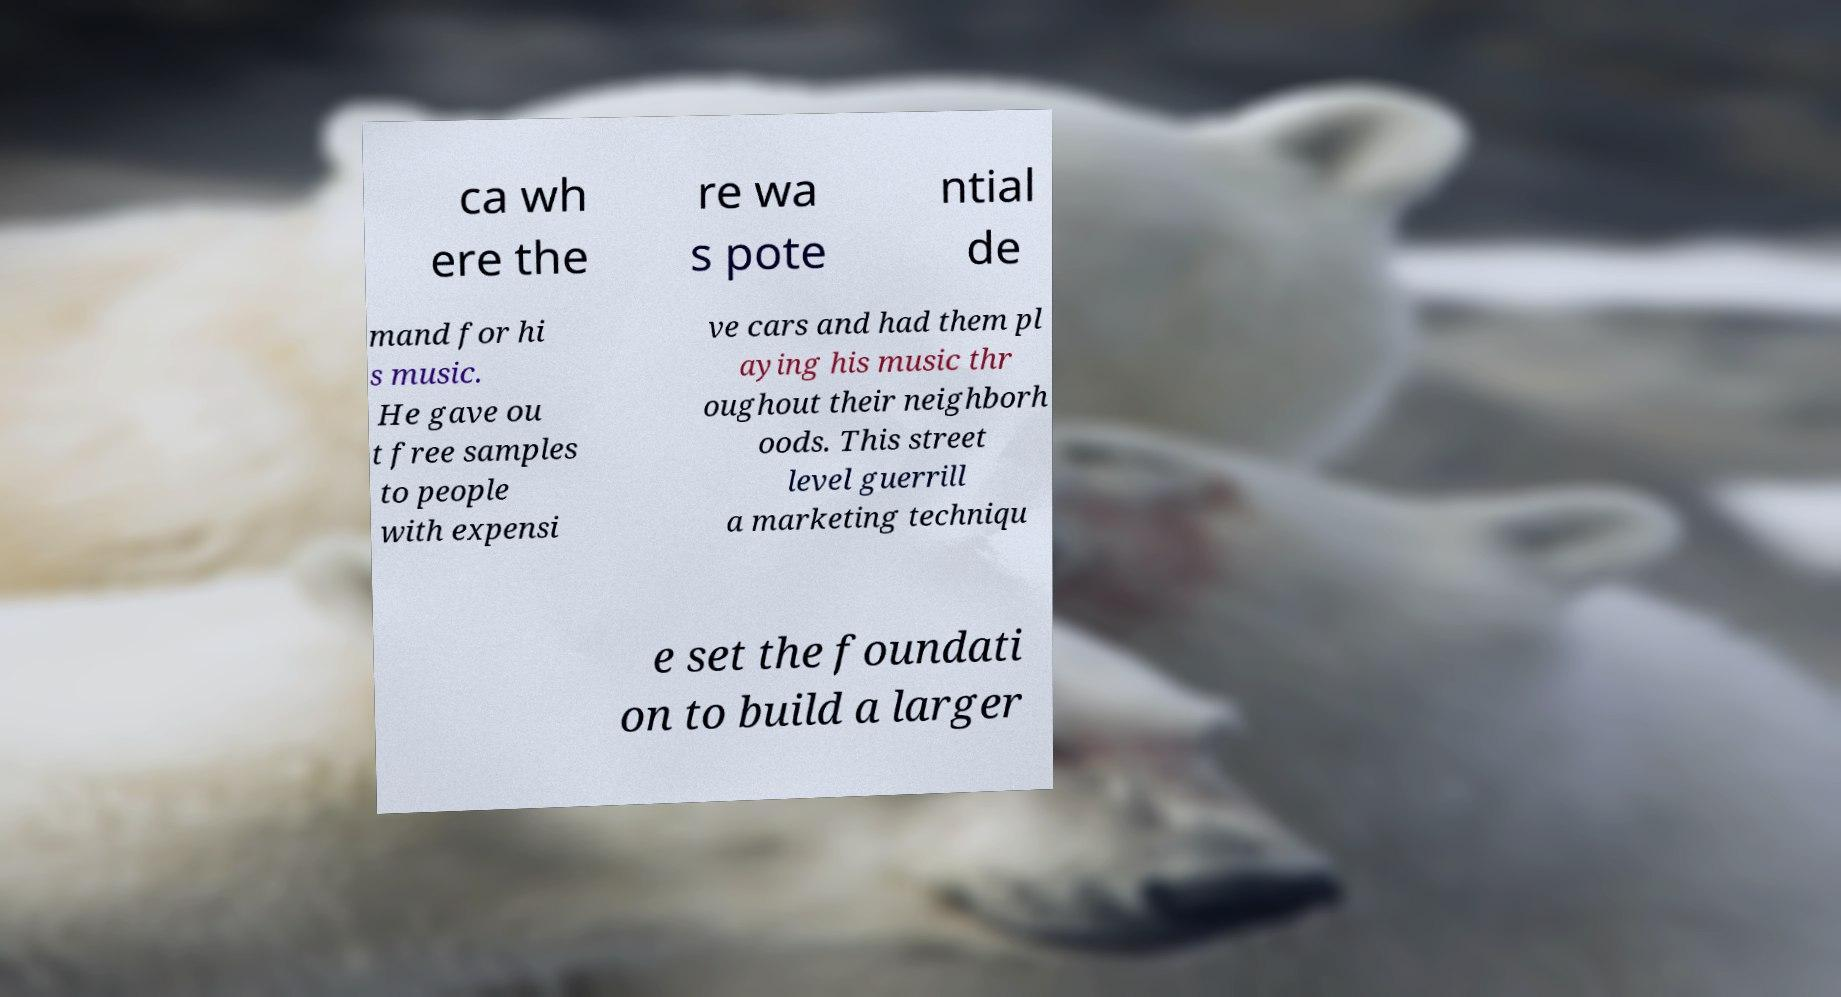Could you extract and type out the text from this image? ca wh ere the re wa s pote ntial de mand for hi s music. He gave ou t free samples to people with expensi ve cars and had them pl aying his music thr oughout their neighborh oods. This street level guerrill a marketing techniqu e set the foundati on to build a larger 